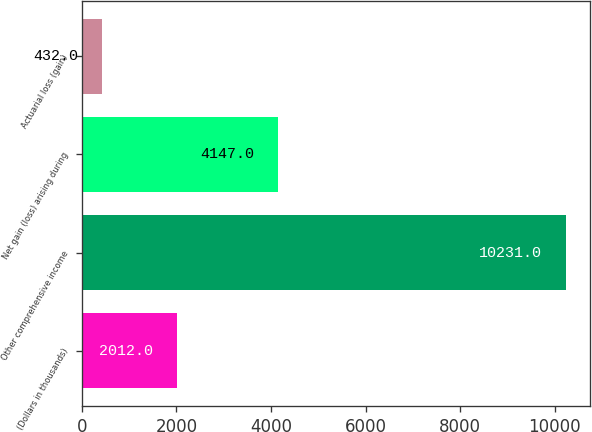<chart> <loc_0><loc_0><loc_500><loc_500><bar_chart><fcel>(Dollars in thousands)<fcel>Other comprehensive income<fcel>Net gain (loss) arising during<fcel>Actuarial loss (gain)<nl><fcel>2012<fcel>10231<fcel>4147<fcel>432<nl></chart> 